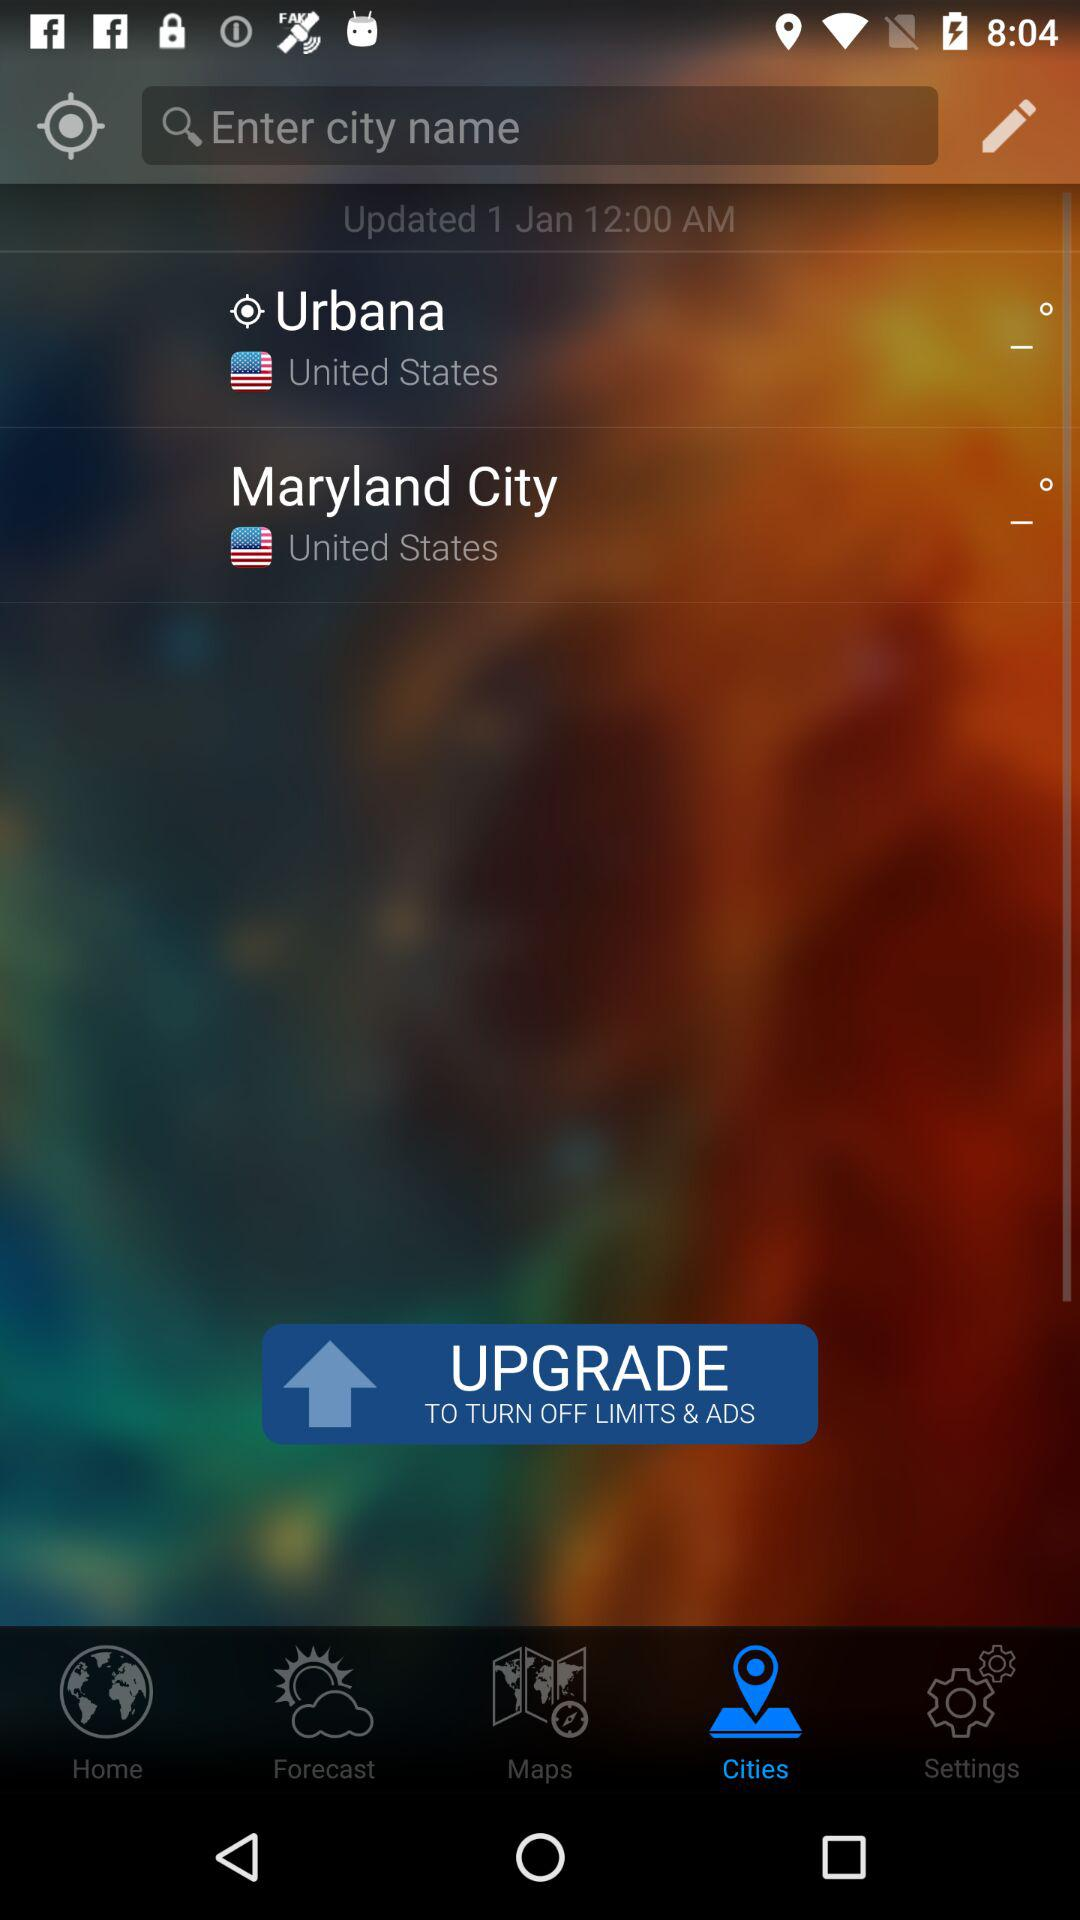What are the available city options? The available city options are Urbana and Maryland City. 